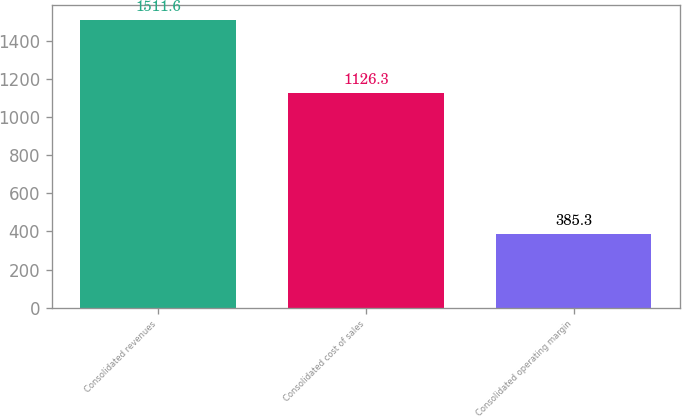<chart> <loc_0><loc_0><loc_500><loc_500><bar_chart><fcel>Consolidated revenues<fcel>Consolidated cost of sales<fcel>Consolidated operating margin<nl><fcel>1511.6<fcel>1126.3<fcel>385.3<nl></chart> 